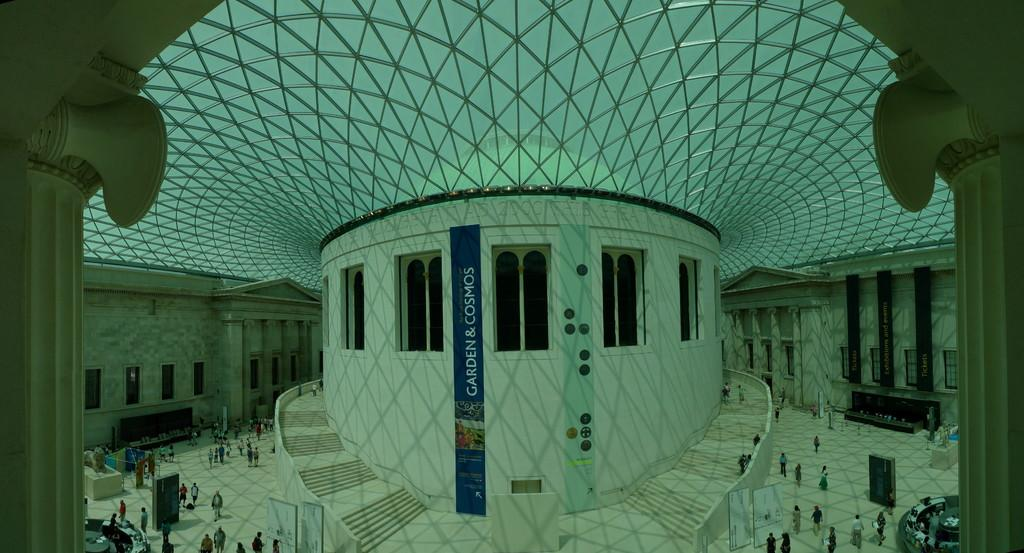What type of location is depicted in the image? The image shows an inside view of a building. What can be seen hanging in the image? There is a banner in the image. What architectural feature is visible in the image? Windows are visible in the image. What might be used for ascending or descending in the image? Steps are present in the image. What structural elements support the building in the image? Pillars are in the image. What else is present in the image besides the architectural features? There are objects in the image. What is the position of the group of people in the image? A group of people is on the floor in the image. What type of channel is being used to paint the design on the canvas in the image? There is no channel or canvas present in the image; it shows an inside view of a building with a group of people on the floor. 